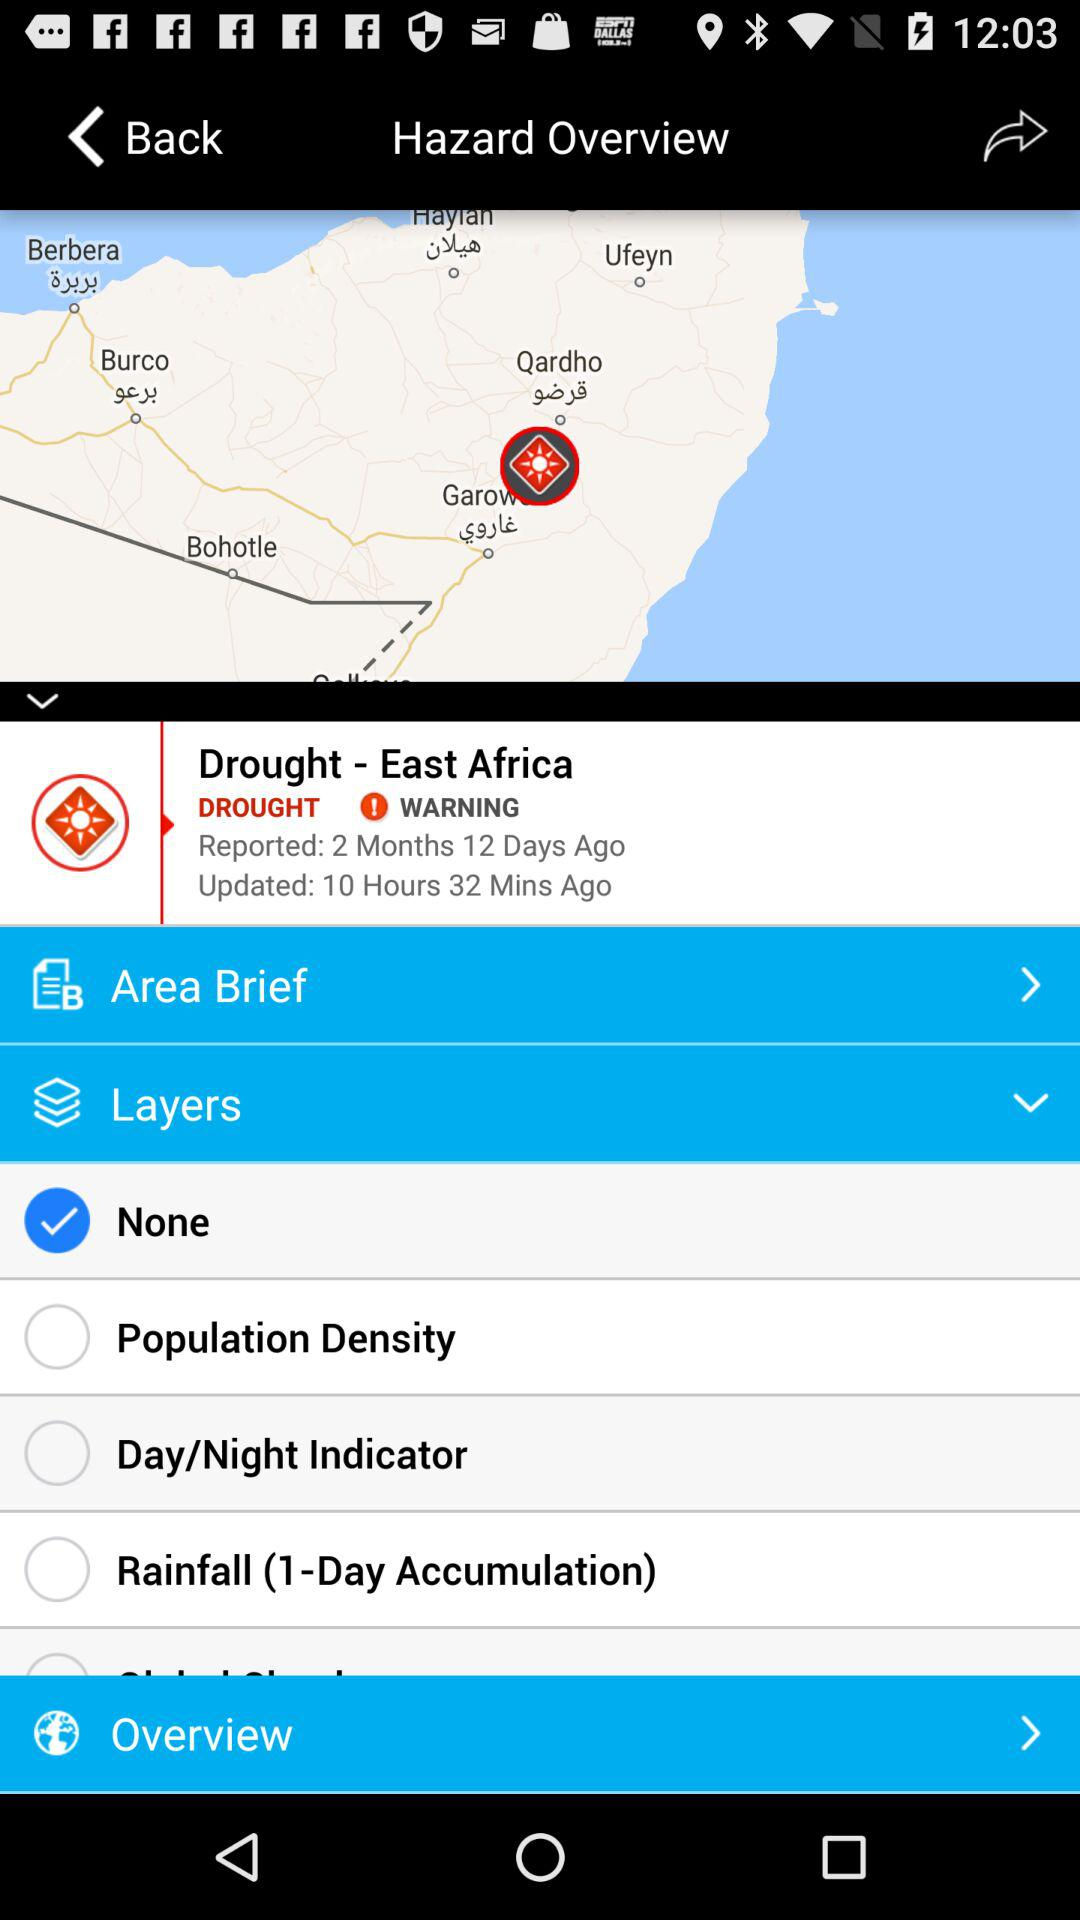What is the reported date? The reported date is 2 months and 12 days ago. 